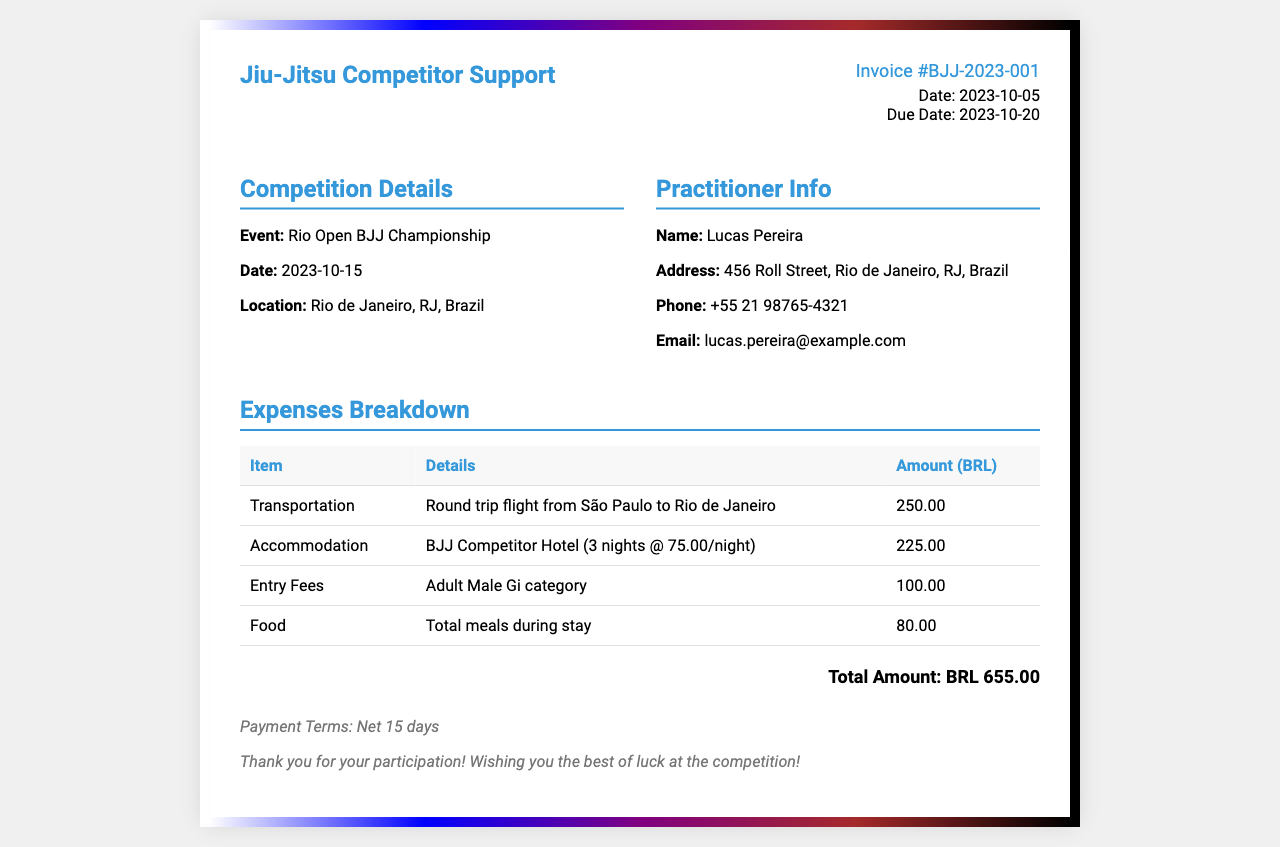What is the invoice number? The invoice number is listed prominently in the document, helping identify this specific invoice.
Answer: BJJ-2023-001 What date is the invoice issued? The date of issue is indicated clearly, essential for payment tracking.
Answer: 2023-10-05 Who is the practitioner? This question targets the individual's name, which is stated in the document's information section.
Answer: Lucas Pereira What is the total amount for the expenses? The total amount is calculated by summing all the individual expense amounts listed in the table.
Answer: BRL 655.00 How many nights of accommodation are charged? The document specifies the total cost and the nightly rate, allowing for this calculation.
Answer: 3 nights What is the purpose of the "notes" section? This section provides additional information regarding payment terms and appreciation for the competition participation.
Answer: Payment Terms How much is charged for food expenses? The document lists a specific amount for meals during the stay, directly indicating food expenses.
Answer: 80.00 What event is this invoice for? Identifying the event helps understand the context of the expenses incurred.
Answer: Rio Open BJJ Championship When is the payment due? The due date for payment is critical for financial planning and obligations.
Answer: 2023-10-20 